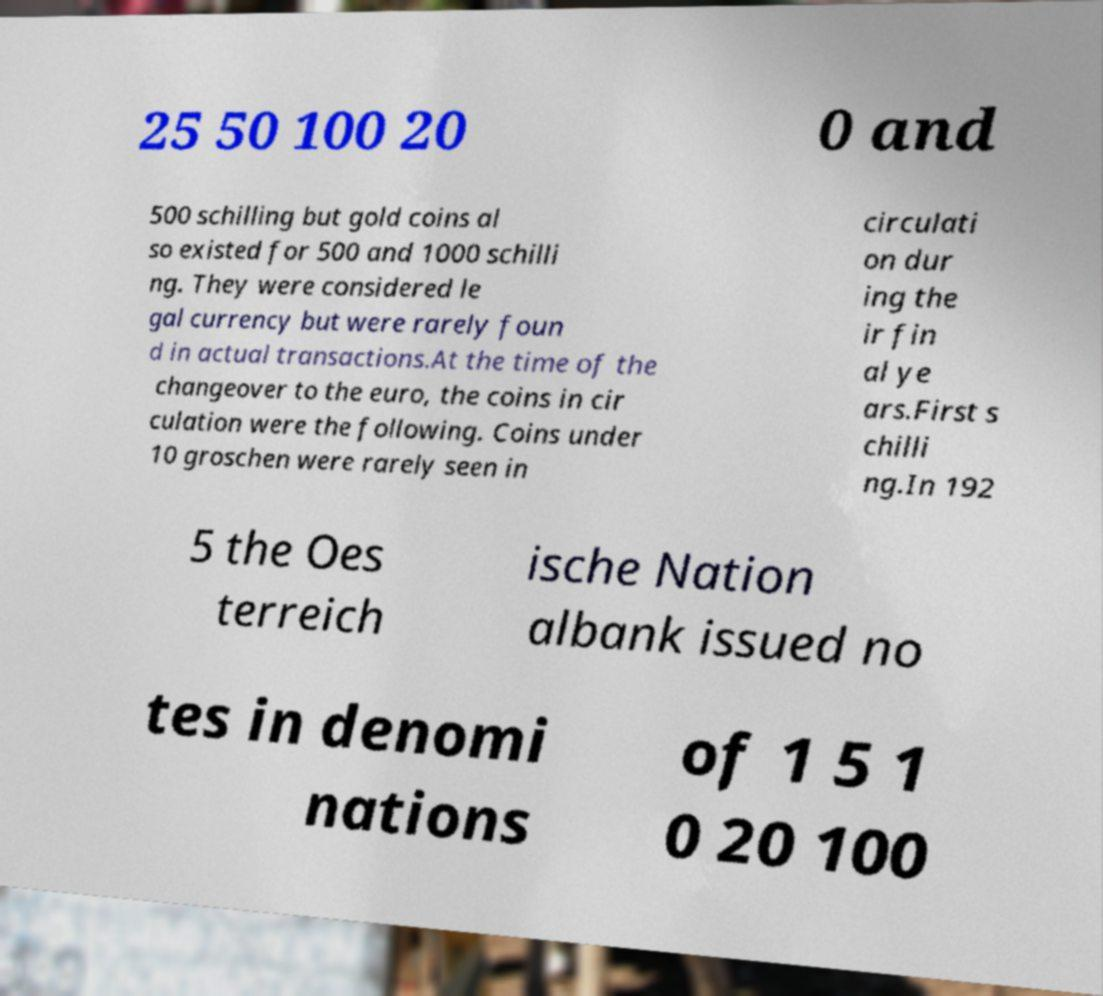For documentation purposes, I need the text within this image transcribed. Could you provide that? 25 50 100 20 0 and 500 schilling but gold coins al so existed for 500 and 1000 schilli ng. They were considered le gal currency but were rarely foun d in actual transactions.At the time of the changeover to the euro, the coins in cir culation were the following. Coins under 10 groschen were rarely seen in circulati on dur ing the ir fin al ye ars.First s chilli ng.In 192 5 the Oes terreich ische Nation albank issued no tes in denomi nations of 1 5 1 0 20 100 